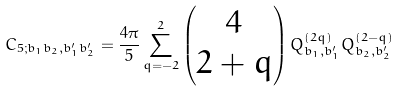<formula> <loc_0><loc_0><loc_500><loc_500>C _ { 5 ; b _ { 1 } b _ { 2 } , b _ { 1 } ^ { \prime } b _ { 2 } ^ { \prime } } = \frac { 4 \pi } { 5 } \sum _ { q = - 2 } ^ { 2 } \begin{pmatrix} 4 \\ 2 + q \end{pmatrix} Q ^ { ( 2 q ) } _ { b _ { 1 } , b _ { 1 } ^ { \prime } } Q ^ { ( 2 - q ) } _ { b _ { 2 } , b _ { 2 } ^ { \prime } }</formula> 